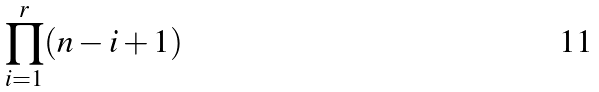<formula> <loc_0><loc_0><loc_500><loc_500>\prod _ { i = 1 } ^ { r } ( n - i + 1 )</formula> 